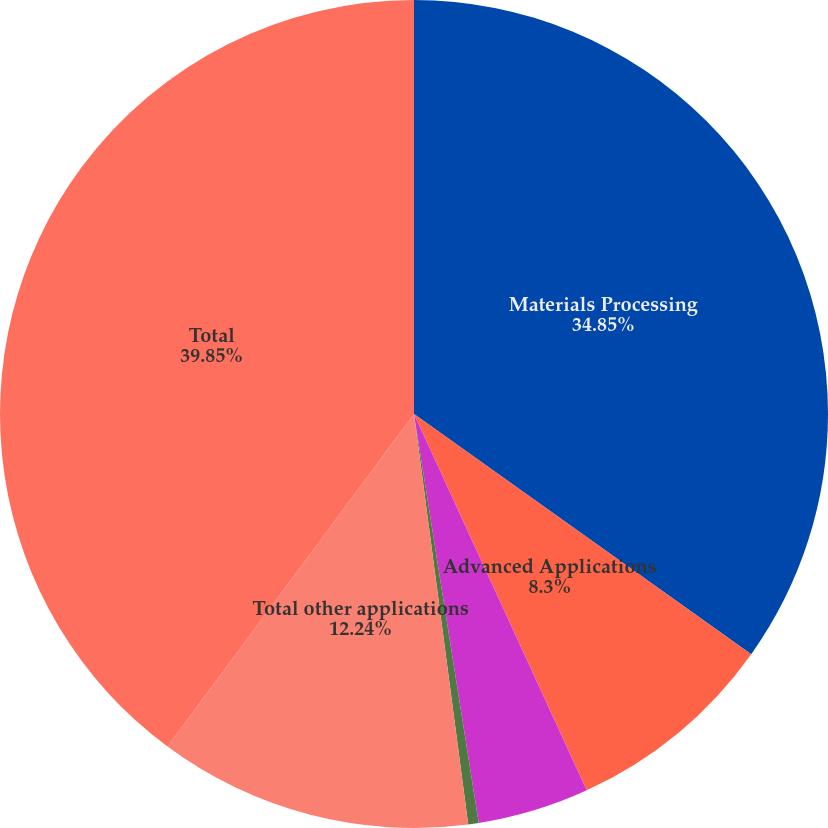<chart> <loc_0><loc_0><loc_500><loc_500><pie_chart><fcel>Materials Processing<fcel>Advanced Applications<fcel>Communications<fcel>Medical<fcel>Total other applications<fcel>Total<nl><fcel>34.85%<fcel>8.3%<fcel>4.35%<fcel>0.41%<fcel>12.24%<fcel>39.85%<nl></chart> 